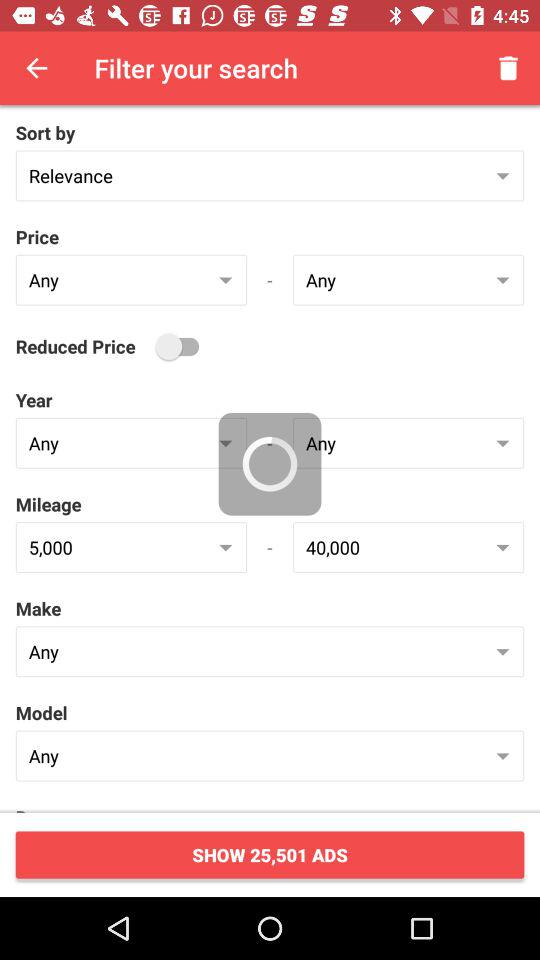How many ads is it asking to show? The number of ads it is asking to show is 25,501. 